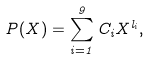<formula> <loc_0><loc_0><loc_500><loc_500>P ( X ) = \sum _ { i = 1 } ^ { 9 } C _ { i } X ^ { l _ { i } } ,</formula> 